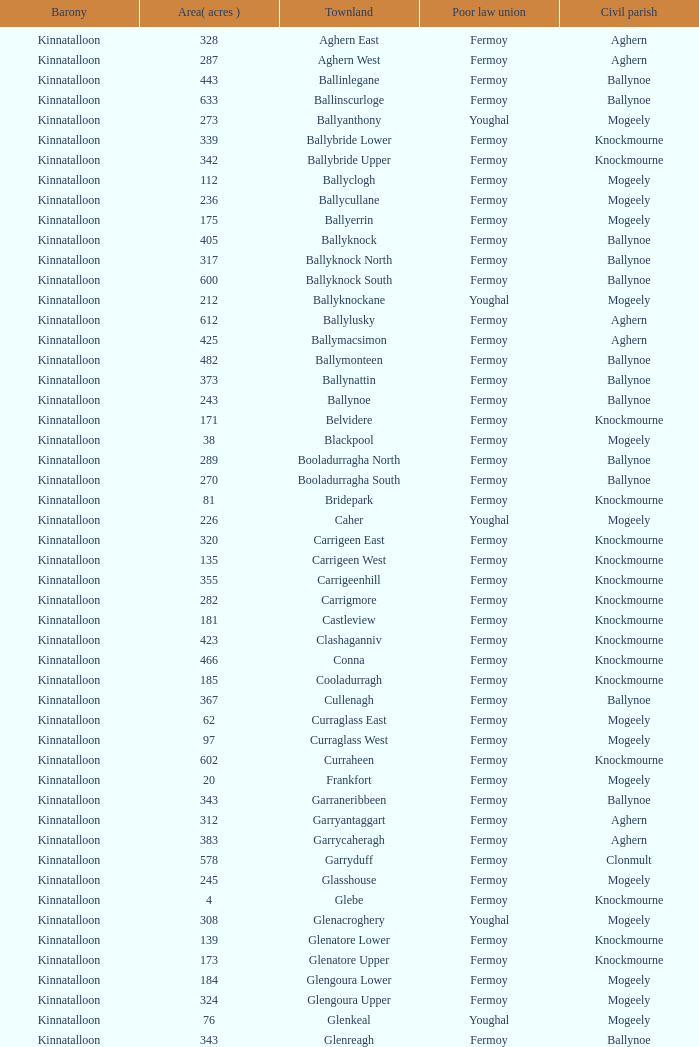Name the civil parish for garryduff Clonmult. 